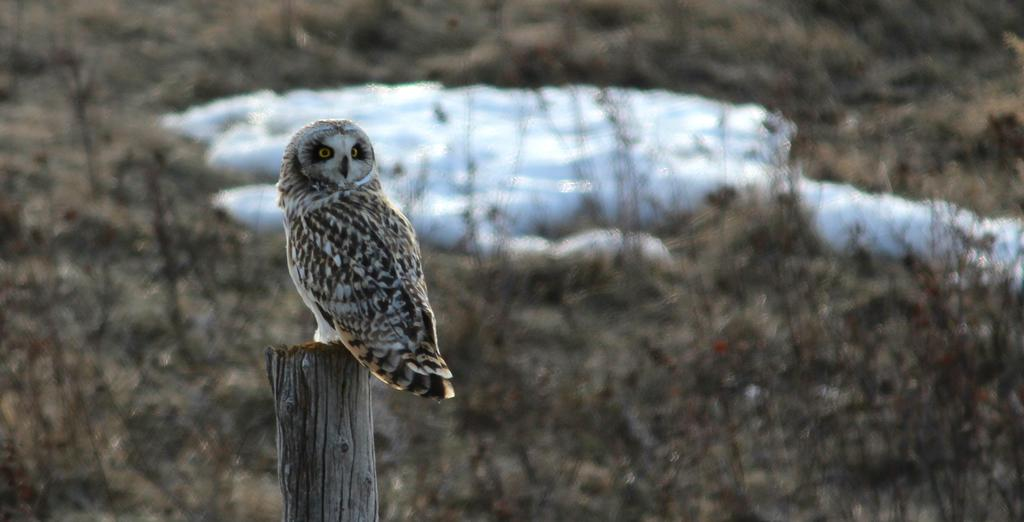What animal is present in the image? There is an owl in the image. What is the owl sitting on? The owl is sitting on a wooden block. What can be seen in the background of the image? There are plants in the background of the image. What type of weather condition is depicted in the image? The image appears to depict snow in the middle. What type of lunchroom can be seen in the image? There is no lunchroom present in the image; it features an owl sitting on a wooden block with plants in the background and snow in the middle. 